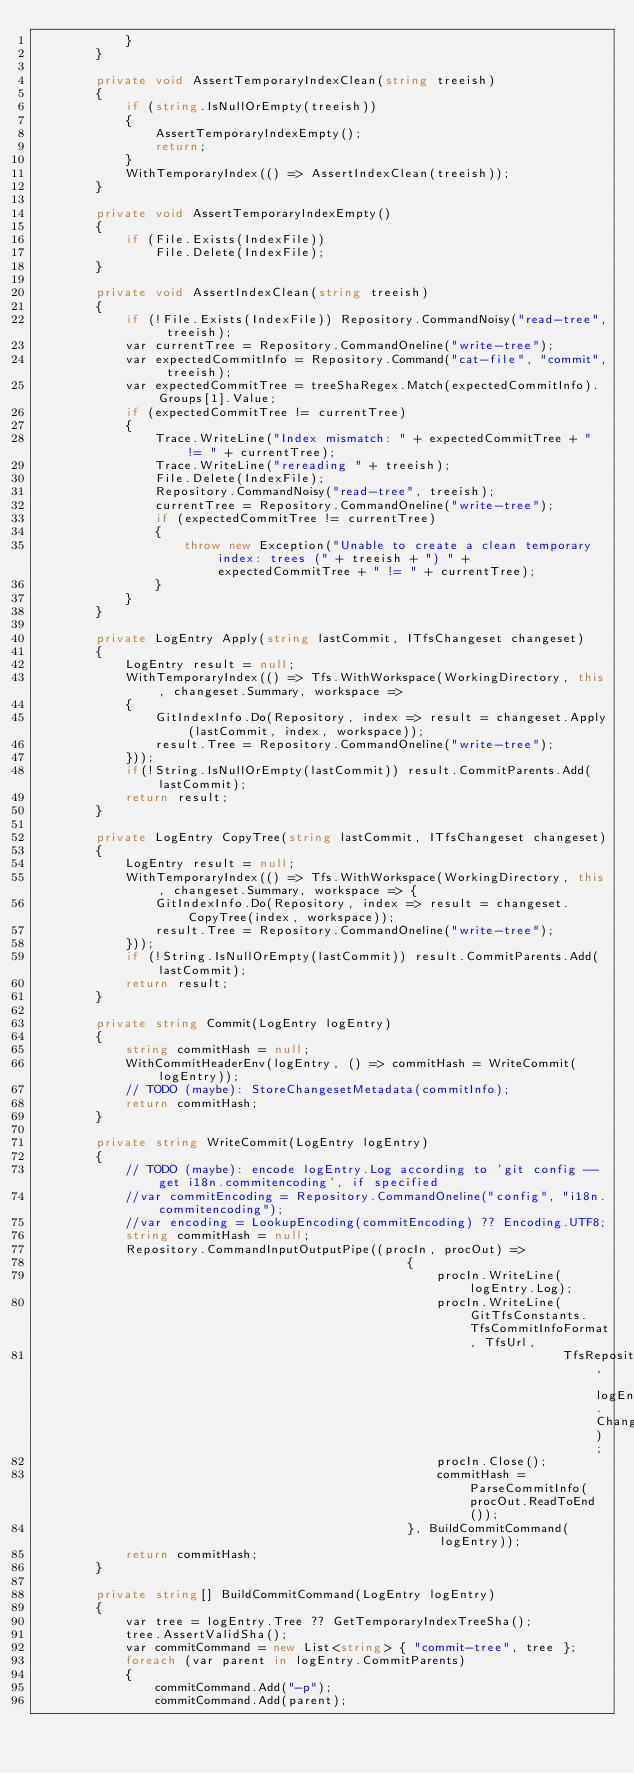<code> <loc_0><loc_0><loc_500><loc_500><_C#_>            }
        }

        private void AssertTemporaryIndexClean(string treeish)
        {
            if (string.IsNullOrEmpty(treeish))
            {
                AssertTemporaryIndexEmpty();
                return;
            }
            WithTemporaryIndex(() => AssertIndexClean(treeish));
        }

        private void AssertTemporaryIndexEmpty()
        {
            if (File.Exists(IndexFile))
                File.Delete(IndexFile);
        }

        private void AssertIndexClean(string treeish)
        {
            if (!File.Exists(IndexFile)) Repository.CommandNoisy("read-tree", treeish);
            var currentTree = Repository.CommandOneline("write-tree");
            var expectedCommitInfo = Repository.Command("cat-file", "commit", treeish);
            var expectedCommitTree = treeShaRegex.Match(expectedCommitInfo).Groups[1].Value;
            if (expectedCommitTree != currentTree)
            {
                Trace.WriteLine("Index mismatch: " + expectedCommitTree + " != " + currentTree);
                Trace.WriteLine("rereading " + treeish);
                File.Delete(IndexFile);
                Repository.CommandNoisy("read-tree", treeish);
                currentTree = Repository.CommandOneline("write-tree");
                if (expectedCommitTree != currentTree)
                {
                    throw new Exception("Unable to create a clean temporary index: trees (" + treeish + ") " + expectedCommitTree + " != " + currentTree);
                }
            }
        }

        private LogEntry Apply(string lastCommit, ITfsChangeset changeset)
        {
            LogEntry result = null;
            WithTemporaryIndex(() => Tfs.WithWorkspace(WorkingDirectory, this, changeset.Summary, workspace =>
            {
                GitIndexInfo.Do(Repository, index => result = changeset.Apply(lastCommit, index, workspace));
                result.Tree = Repository.CommandOneline("write-tree");
            }));
            if(!String.IsNullOrEmpty(lastCommit)) result.CommitParents.Add(lastCommit);
            return result;
        }

        private LogEntry CopyTree(string lastCommit, ITfsChangeset changeset)
        {
            LogEntry result = null;
            WithTemporaryIndex(() => Tfs.WithWorkspace(WorkingDirectory, this, changeset.Summary, workspace => {
                GitIndexInfo.Do(Repository, index => result = changeset.CopyTree(index, workspace));
                result.Tree = Repository.CommandOneline("write-tree");
            }));
            if (!String.IsNullOrEmpty(lastCommit)) result.CommitParents.Add(lastCommit);
            return result;
        }

        private string Commit(LogEntry logEntry)
        {
            string commitHash = null;
            WithCommitHeaderEnv(logEntry, () => commitHash = WriteCommit(logEntry));
            // TODO (maybe): StoreChangesetMetadata(commitInfo);
            return commitHash;
        }

        private string WriteCommit(LogEntry logEntry)
        {
            // TODO (maybe): encode logEntry.Log according to 'git config --get i18n.commitencoding', if specified
            //var commitEncoding = Repository.CommandOneline("config", "i18n.commitencoding");
            //var encoding = LookupEncoding(commitEncoding) ?? Encoding.UTF8;
            string commitHash = null;
            Repository.CommandInputOutputPipe((procIn, procOut) =>
                                                  {
                                                      procIn.WriteLine(logEntry.Log);
                                                      procIn.WriteLine(GitTfsConstants.TfsCommitInfoFormat, TfsUrl,
                                                                       TfsRepositoryPath, logEntry.ChangesetId);
                                                      procIn.Close();
                                                      commitHash = ParseCommitInfo(procOut.ReadToEnd());
                                                  }, BuildCommitCommand(logEntry));
            return commitHash;
        }

        private string[] BuildCommitCommand(LogEntry logEntry)
        {
            var tree = logEntry.Tree ?? GetTemporaryIndexTreeSha();
            tree.AssertValidSha();
            var commitCommand = new List<string> { "commit-tree", tree };
            foreach (var parent in logEntry.CommitParents)
            {
                commitCommand.Add("-p");
                commitCommand.Add(parent);</code> 